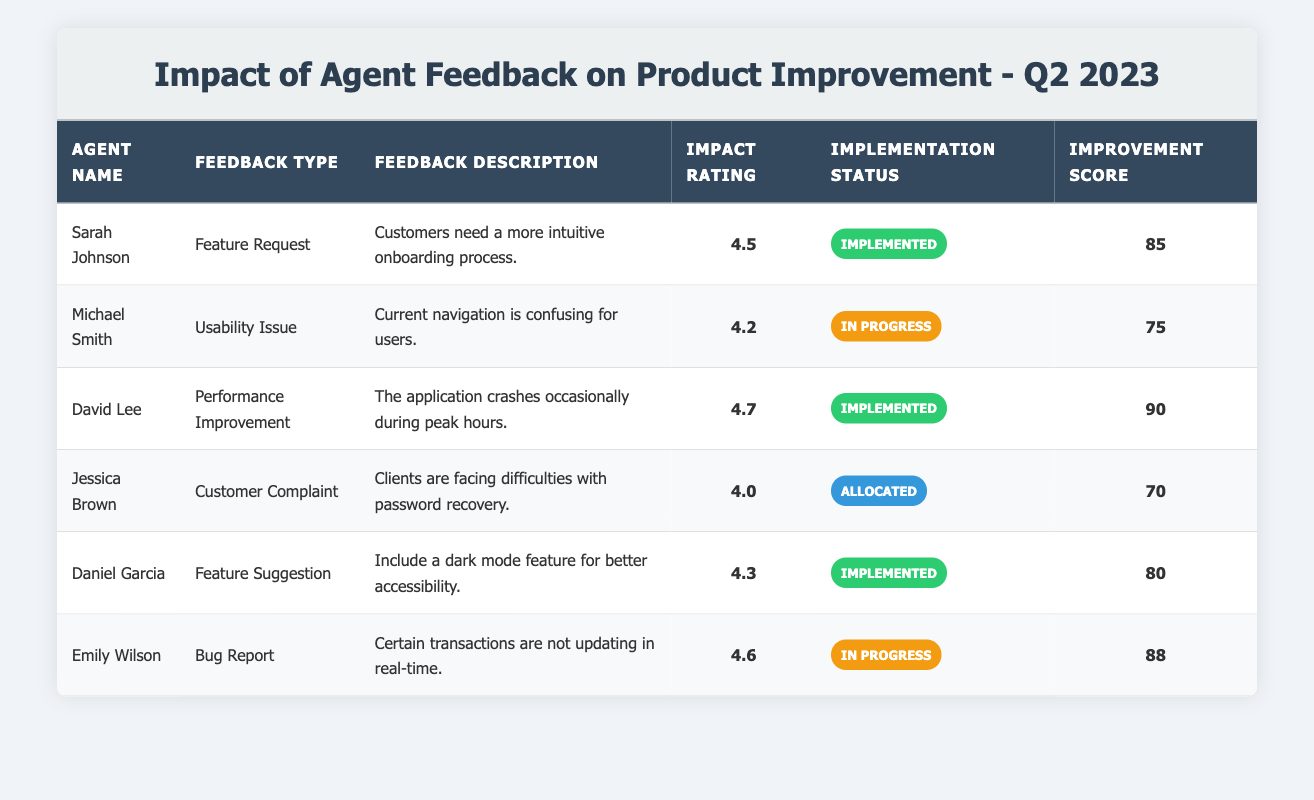What is the impact rating of the feedback provided by Sarah Johnson? The feedback provided by Sarah Johnson has an impact rating of 4.5 as indicated in the table.
Answer: 4.5 How many agents had their feedback implemented? Four agents had their feedback implemented: Sarah Johnson, David Lee, Daniel Garcia, and one other.
Answer: 4 What is the feedback description for the agent who reported a bug? Emily Wilson reported that certain transactions are not updating in real-time, which is the feedback description associated with her feedback type of Bug Report.
Answer: Certain transactions are not updating in real-time Which agent has the highest impact rating, and what type of feedback did they provide? David Lee has the highest impact rating of 4.7 and provided feedback categorized as Performance Improvement regarding application crashes.
Answer: David Lee, Performance Improvement What is the average improvement score for the implemented feedback? The improvement scores for implemented feedback are 85, 90, and 80. The average is calculated as (85 + 90 + 80) / 3 = 85.
Answer: 85 Is there any feedback that is currently in progress but has an impact rating below 4.5? Yes, Michael Smith's feedback on navigation is in progress and has an impact rating of 4.2, which is below 4.5 as stated in the table.
Answer: Yes Which feedback type has the lowest improvement score across all agents? Jessica Brown's Customer Complaint feedback has the lowest improvement score of 70 among all feedback types as seen in the table.
Answer: Customer Complaint What is the difference between the maximum and minimum impact ratings in the table? The maximum impact rating is 4.7 (by David Lee), and the minimum impact rating is 4.0 (by Jessica Brown). The difference is 4.7 - 4.0 = 0.7.
Answer: 0.7 How many types of feedback are documented in the table? There are five distinct types of feedback documented: Feature Request, Usability Issue, Performance Improvement, Customer Complaint, and Bug Report.
Answer: 5 